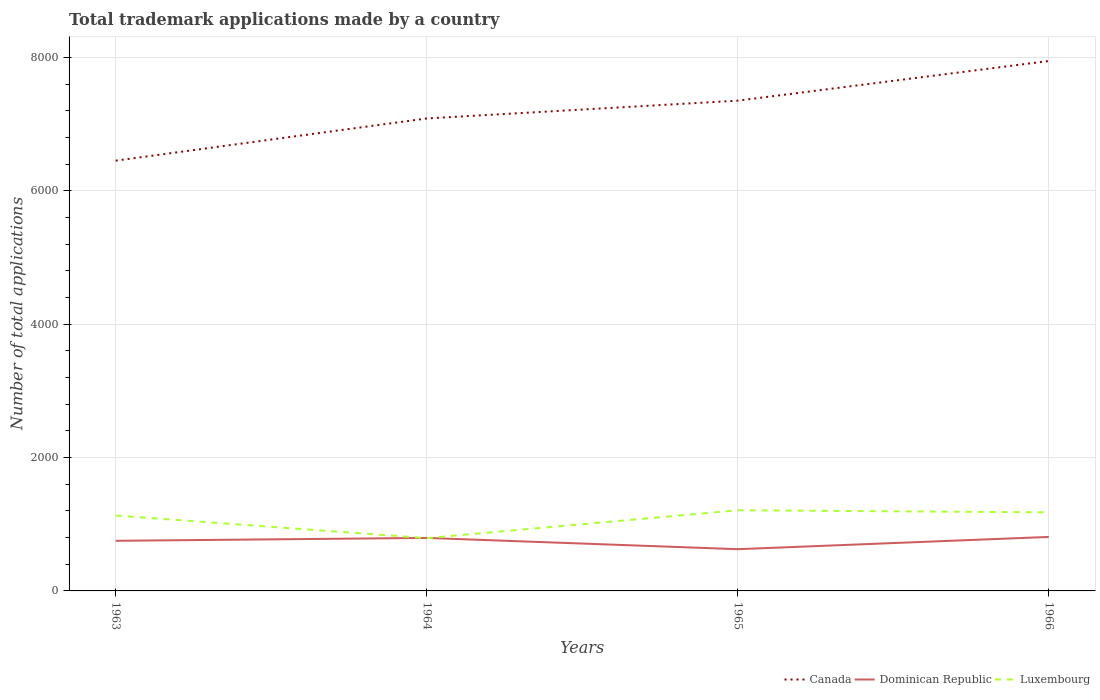Across all years, what is the maximum number of applications made by in Canada?
Provide a succinct answer. 6455. In which year was the number of applications made by in Dominican Republic maximum?
Your answer should be compact. 1965. What is the total number of applications made by in Luxembourg in the graph?
Keep it short and to the point. -387. What is the difference between the highest and the second highest number of applications made by in Canada?
Offer a terse response. 1495. Is the number of applications made by in Dominican Republic strictly greater than the number of applications made by in Luxembourg over the years?
Give a very brief answer. No. Does the graph contain grids?
Provide a short and direct response. Yes. What is the title of the graph?
Your answer should be very brief. Total trademark applications made by a country. Does "East Asia (all income levels)" appear as one of the legend labels in the graph?
Keep it short and to the point. No. What is the label or title of the Y-axis?
Provide a succinct answer. Number of total applications. What is the Number of total applications of Canada in 1963?
Ensure brevity in your answer.  6455. What is the Number of total applications of Dominican Republic in 1963?
Keep it short and to the point. 752. What is the Number of total applications of Luxembourg in 1963?
Make the answer very short. 1131. What is the Number of total applications of Canada in 1964?
Offer a terse response. 7088. What is the Number of total applications in Dominican Republic in 1964?
Make the answer very short. 795. What is the Number of total applications of Luxembourg in 1964?
Your answer should be very brief. 792. What is the Number of total applications of Canada in 1965?
Give a very brief answer. 7355. What is the Number of total applications of Dominican Republic in 1965?
Give a very brief answer. 626. What is the Number of total applications in Luxembourg in 1965?
Ensure brevity in your answer.  1210. What is the Number of total applications in Canada in 1966?
Your answer should be compact. 7950. What is the Number of total applications in Dominican Republic in 1966?
Your response must be concise. 810. What is the Number of total applications of Luxembourg in 1966?
Offer a terse response. 1179. Across all years, what is the maximum Number of total applications of Canada?
Ensure brevity in your answer.  7950. Across all years, what is the maximum Number of total applications of Dominican Republic?
Offer a terse response. 810. Across all years, what is the maximum Number of total applications of Luxembourg?
Offer a very short reply. 1210. Across all years, what is the minimum Number of total applications of Canada?
Ensure brevity in your answer.  6455. Across all years, what is the minimum Number of total applications of Dominican Republic?
Your answer should be compact. 626. Across all years, what is the minimum Number of total applications in Luxembourg?
Keep it short and to the point. 792. What is the total Number of total applications of Canada in the graph?
Your answer should be very brief. 2.88e+04. What is the total Number of total applications in Dominican Republic in the graph?
Provide a short and direct response. 2983. What is the total Number of total applications of Luxembourg in the graph?
Provide a short and direct response. 4312. What is the difference between the Number of total applications in Canada in 1963 and that in 1964?
Provide a succinct answer. -633. What is the difference between the Number of total applications of Dominican Republic in 1963 and that in 1964?
Give a very brief answer. -43. What is the difference between the Number of total applications of Luxembourg in 1963 and that in 1964?
Your response must be concise. 339. What is the difference between the Number of total applications of Canada in 1963 and that in 1965?
Offer a terse response. -900. What is the difference between the Number of total applications in Dominican Republic in 1963 and that in 1965?
Provide a succinct answer. 126. What is the difference between the Number of total applications in Luxembourg in 1963 and that in 1965?
Provide a succinct answer. -79. What is the difference between the Number of total applications in Canada in 1963 and that in 1966?
Make the answer very short. -1495. What is the difference between the Number of total applications of Dominican Republic in 1963 and that in 1966?
Make the answer very short. -58. What is the difference between the Number of total applications in Luxembourg in 1963 and that in 1966?
Provide a succinct answer. -48. What is the difference between the Number of total applications in Canada in 1964 and that in 1965?
Offer a terse response. -267. What is the difference between the Number of total applications of Dominican Republic in 1964 and that in 1965?
Provide a succinct answer. 169. What is the difference between the Number of total applications of Luxembourg in 1964 and that in 1965?
Your answer should be compact. -418. What is the difference between the Number of total applications of Canada in 1964 and that in 1966?
Give a very brief answer. -862. What is the difference between the Number of total applications of Luxembourg in 1964 and that in 1966?
Provide a short and direct response. -387. What is the difference between the Number of total applications of Canada in 1965 and that in 1966?
Give a very brief answer. -595. What is the difference between the Number of total applications in Dominican Republic in 1965 and that in 1966?
Ensure brevity in your answer.  -184. What is the difference between the Number of total applications in Canada in 1963 and the Number of total applications in Dominican Republic in 1964?
Your answer should be compact. 5660. What is the difference between the Number of total applications of Canada in 1963 and the Number of total applications of Luxembourg in 1964?
Your answer should be very brief. 5663. What is the difference between the Number of total applications in Dominican Republic in 1963 and the Number of total applications in Luxembourg in 1964?
Your answer should be compact. -40. What is the difference between the Number of total applications in Canada in 1963 and the Number of total applications in Dominican Republic in 1965?
Provide a succinct answer. 5829. What is the difference between the Number of total applications in Canada in 1963 and the Number of total applications in Luxembourg in 1965?
Offer a terse response. 5245. What is the difference between the Number of total applications in Dominican Republic in 1963 and the Number of total applications in Luxembourg in 1965?
Offer a very short reply. -458. What is the difference between the Number of total applications in Canada in 1963 and the Number of total applications in Dominican Republic in 1966?
Your response must be concise. 5645. What is the difference between the Number of total applications in Canada in 1963 and the Number of total applications in Luxembourg in 1966?
Ensure brevity in your answer.  5276. What is the difference between the Number of total applications in Dominican Republic in 1963 and the Number of total applications in Luxembourg in 1966?
Give a very brief answer. -427. What is the difference between the Number of total applications in Canada in 1964 and the Number of total applications in Dominican Republic in 1965?
Your answer should be very brief. 6462. What is the difference between the Number of total applications of Canada in 1964 and the Number of total applications of Luxembourg in 1965?
Make the answer very short. 5878. What is the difference between the Number of total applications of Dominican Republic in 1964 and the Number of total applications of Luxembourg in 1965?
Keep it short and to the point. -415. What is the difference between the Number of total applications in Canada in 1964 and the Number of total applications in Dominican Republic in 1966?
Your answer should be very brief. 6278. What is the difference between the Number of total applications of Canada in 1964 and the Number of total applications of Luxembourg in 1966?
Ensure brevity in your answer.  5909. What is the difference between the Number of total applications in Dominican Republic in 1964 and the Number of total applications in Luxembourg in 1966?
Offer a terse response. -384. What is the difference between the Number of total applications of Canada in 1965 and the Number of total applications of Dominican Republic in 1966?
Provide a short and direct response. 6545. What is the difference between the Number of total applications in Canada in 1965 and the Number of total applications in Luxembourg in 1966?
Offer a terse response. 6176. What is the difference between the Number of total applications of Dominican Republic in 1965 and the Number of total applications of Luxembourg in 1966?
Offer a very short reply. -553. What is the average Number of total applications of Canada per year?
Offer a very short reply. 7212. What is the average Number of total applications of Dominican Republic per year?
Make the answer very short. 745.75. What is the average Number of total applications in Luxembourg per year?
Make the answer very short. 1078. In the year 1963, what is the difference between the Number of total applications in Canada and Number of total applications in Dominican Republic?
Your answer should be very brief. 5703. In the year 1963, what is the difference between the Number of total applications of Canada and Number of total applications of Luxembourg?
Offer a very short reply. 5324. In the year 1963, what is the difference between the Number of total applications in Dominican Republic and Number of total applications in Luxembourg?
Your answer should be compact. -379. In the year 1964, what is the difference between the Number of total applications in Canada and Number of total applications in Dominican Republic?
Your response must be concise. 6293. In the year 1964, what is the difference between the Number of total applications in Canada and Number of total applications in Luxembourg?
Give a very brief answer. 6296. In the year 1964, what is the difference between the Number of total applications of Dominican Republic and Number of total applications of Luxembourg?
Offer a very short reply. 3. In the year 1965, what is the difference between the Number of total applications in Canada and Number of total applications in Dominican Republic?
Provide a short and direct response. 6729. In the year 1965, what is the difference between the Number of total applications in Canada and Number of total applications in Luxembourg?
Your answer should be compact. 6145. In the year 1965, what is the difference between the Number of total applications in Dominican Republic and Number of total applications in Luxembourg?
Provide a succinct answer. -584. In the year 1966, what is the difference between the Number of total applications of Canada and Number of total applications of Dominican Republic?
Your response must be concise. 7140. In the year 1966, what is the difference between the Number of total applications of Canada and Number of total applications of Luxembourg?
Offer a very short reply. 6771. In the year 1966, what is the difference between the Number of total applications in Dominican Republic and Number of total applications in Luxembourg?
Your response must be concise. -369. What is the ratio of the Number of total applications of Canada in 1963 to that in 1964?
Ensure brevity in your answer.  0.91. What is the ratio of the Number of total applications of Dominican Republic in 1963 to that in 1964?
Provide a succinct answer. 0.95. What is the ratio of the Number of total applications of Luxembourg in 1963 to that in 1964?
Ensure brevity in your answer.  1.43. What is the ratio of the Number of total applications of Canada in 1963 to that in 1965?
Provide a succinct answer. 0.88. What is the ratio of the Number of total applications of Dominican Republic in 1963 to that in 1965?
Ensure brevity in your answer.  1.2. What is the ratio of the Number of total applications in Luxembourg in 1963 to that in 1965?
Your answer should be compact. 0.93. What is the ratio of the Number of total applications of Canada in 1963 to that in 1966?
Offer a terse response. 0.81. What is the ratio of the Number of total applications in Dominican Republic in 1963 to that in 1966?
Your answer should be very brief. 0.93. What is the ratio of the Number of total applications of Luxembourg in 1963 to that in 1966?
Give a very brief answer. 0.96. What is the ratio of the Number of total applications of Canada in 1964 to that in 1965?
Your response must be concise. 0.96. What is the ratio of the Number of total applications of Dominican Republic in 1964 to that in 1965?
Offer a terse response. 1.27. What is the ratio of the Number of total applications of Luxembourg in 1964 to that in 1965?
Offer a terse response. 0.65. What is the ratio of the Number of total applications in Canada in 1964 to that in 1966?
Your answer should be very brief. 0.89. What is the ratio of the Number of total applications in Dominican Republic in 1964 to that in 1966?
Provide a succinct answer. 0.98. What is the ratio of the Number of total applications of Luxembourg in 1964 to that in 1966?
Make the answer very short. 0.67. What is the ratio of the Number of total applications in Canada in 1965 to that in 1966?
Your response must be concise. 0.93. What is the ratio of the Number of total applications in Dominican Republic in 1965 to that in 1966?
Offer a terse response. 0.77. What is the ratio of the Number of total applications of Luxembourg in 1965 to that in 1966?
Your answer should be very brief. 1.03. What is the difference between the highest and the second highest Number of total applications of Canada?
Keep it short and to the point. 595. What is the difference between the highest and the second highest Number of total applications in Luxembourg?
Offer a terse response. 31. What is the difference between the highest and the lowest Number of total applications in Canada?
Your answer should be compact. 1495. What is the difference between the highest and the lowest Number of total applications in Dominican Republic?
Ensure brevity in your answer.  184. What is the difference between the highest and the lowest Number of total applications of Luxembourg?
Your response must be concise. 418. 